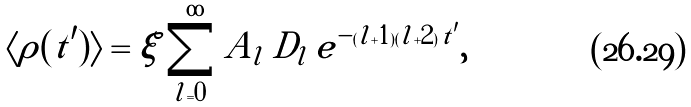<formula> <loc_0><loc_0><loc_500><loc_500>\langle \rho ( t ^ { \prime } ) \rangle = \xi \sum _ { l = 0 } ^ { \infty } A _ { l } \, D _ { l } \, e ^ { - ( l + 1 ) ( l + 2 ) \, t ^ { \prime } } ,</formula> 